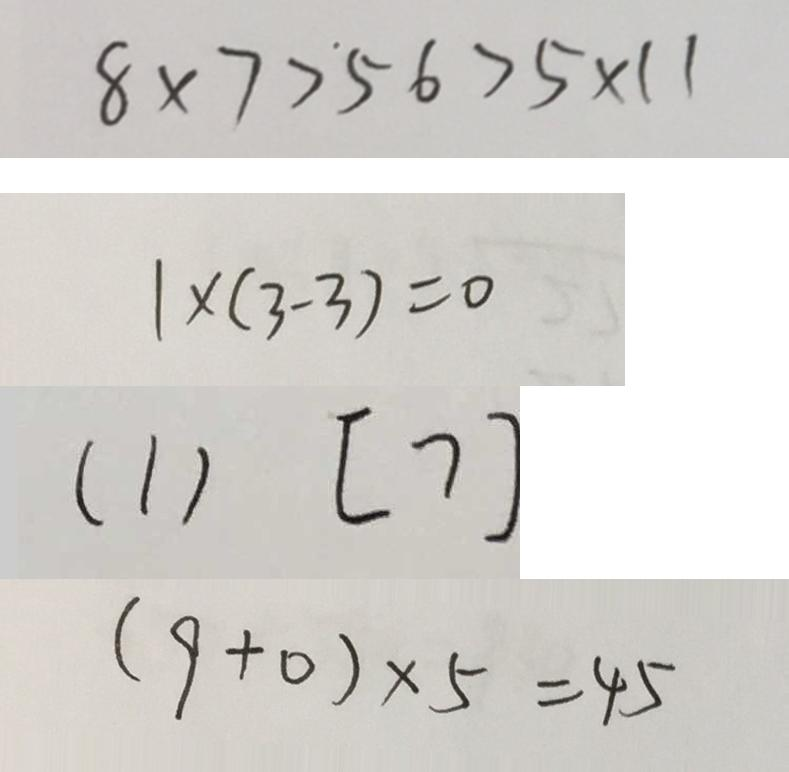Convert formula to latex. <formula><loc_0><loc_0><loc_500><loc_500>8 \times 7 > 5 6 > 5 \times 1 1 
 1 \times ( 3 - 3 ) = 0 
 ( 1 ) [ 7 ] 
 ( 9 + 0 ) \times 5 = 4 5</formula> 